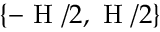<formula> <loc_0><loc_0><loc_500><loc_500>\{ - H / 2 , H / 2 \}</formula> 